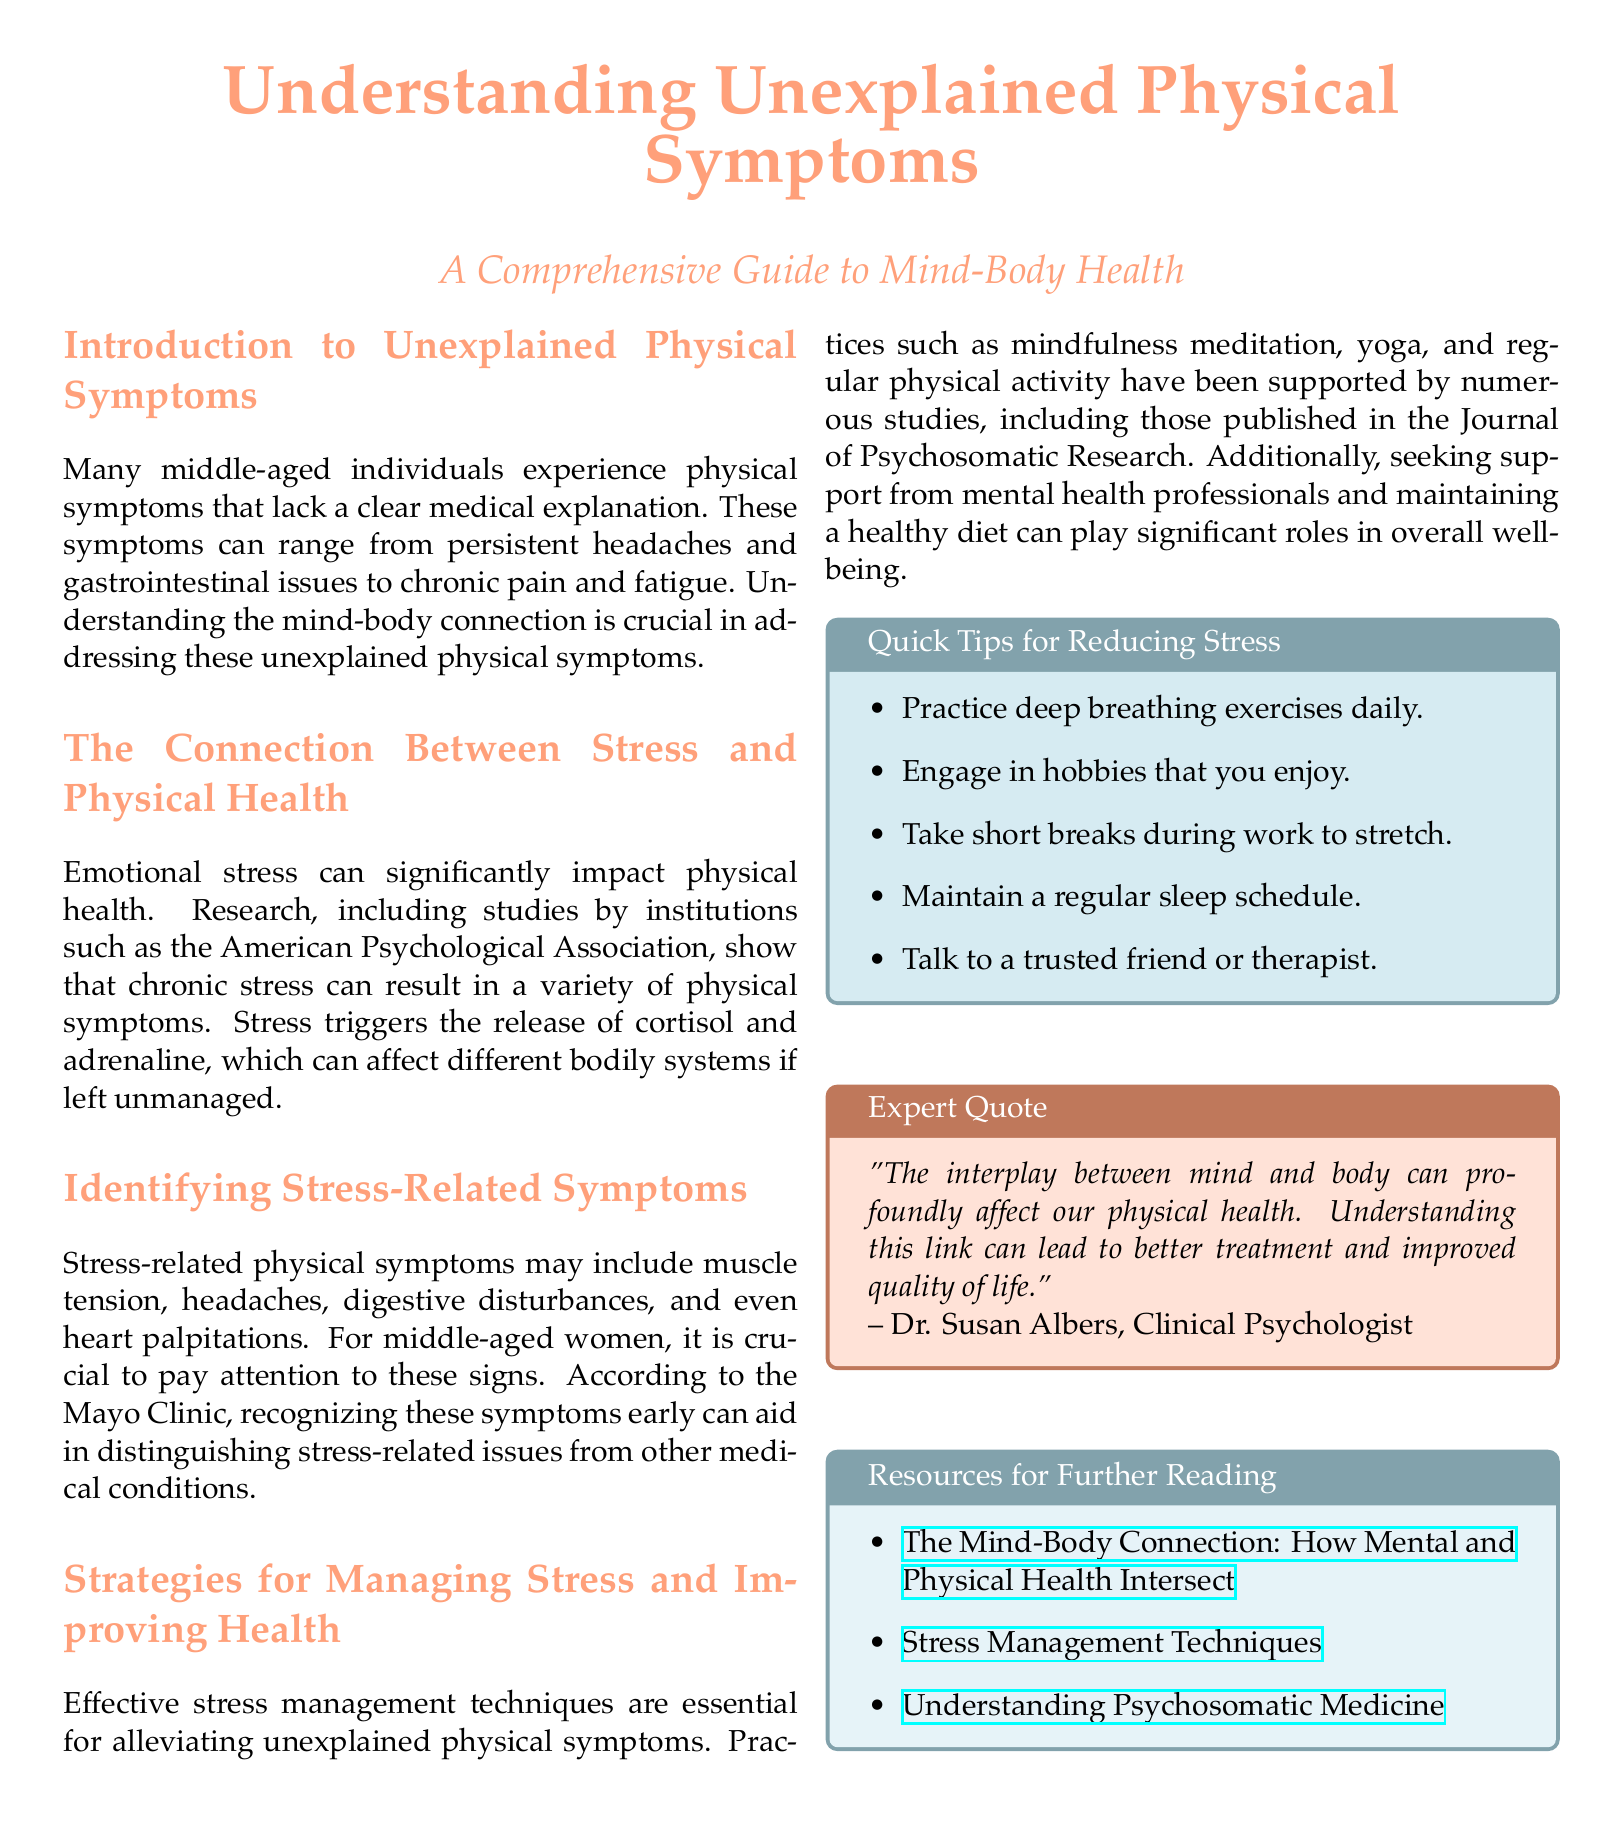What are some examples of unexplained physical symptoms? The section "Introduction to Unexplained Physical Symptoms" lists various physical symptoms that lack a clear medical explanation, such as persistent headaches and gastrointestinal issues.
Answer: Persistent headaches and gastrointestinal issues What triggers the release of cortisol and adrenaline? The section "The Connection Between Stress and Physical Health" explains that emotional stress triggers the release of these hormones.
Answer: Emotional stress What are common stress-related symptoms? The section "Identifying Stress-Related Symptoms" mentions symptoms like muscle tension, headaches, and digestive disturbances.
Answer: Muscle tension, headaches, digestive disturbances What are some stress management techniques mentioned? The section "Strategies for Managing Stress and Improving Health" lists practices such as mindfulness meditation and yoga as effective stress management techniques.
Answer: Mindfulness meditation, yoga Who is quoted in the document regarding mind-body health? In the "Expert Quote" box, Dr. Susan Albers, a Clinical Psychologist, is quoted about the connection between mind and body.
Answer: Dr. Susan Albers What type of document is this? The structured layout with sections and tips suggests this is an article formatted as a newspaper layout.
Answer: Newspaper layout Give an example of a quick tip for reducing stress. The "Quick Tips for Reducing Stress" box offers practical advice, one example being to practice deep breathing exercises daily.
Answer: Practice deep breathing exercises daily What is the purpose of the resources section? The "Resources for Further Reading" section provides additional links for readers to explore topics related to mind-body connection and stress management.
Answer: Additional links for further reading 